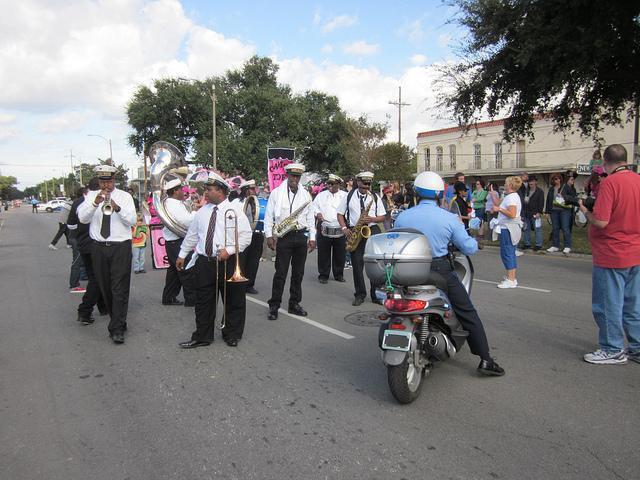How many bikes are there?
Give a very brief answer. 1. How many people are there?
Give a very brief answer. 9. 